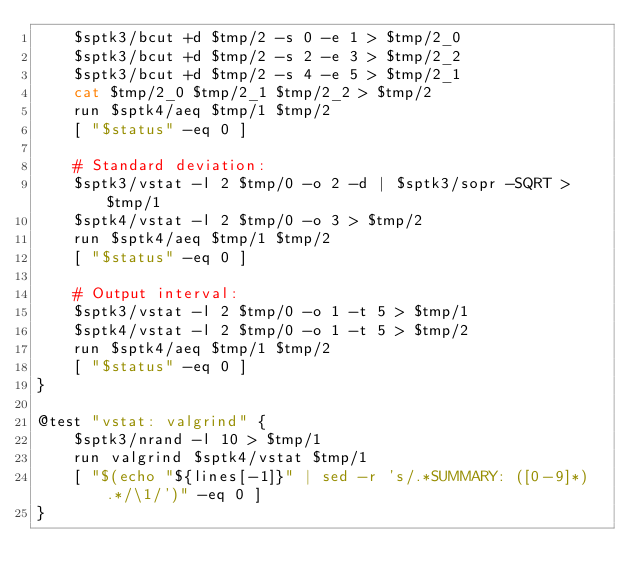<code> <loc_0><loc_0><loc_500><loc_500><_Bash_>    $sptk3/bcut +d $tmp/2 -s 0 -e 1 > $tmp/2_0
    $sptk3/bcut +d $tmp/2 -s 2 -e 3 > $tmp/2_2
    $sptk3/bcut +d $tmp/2 -s 4 -e 5 > $tmp/2_1
    cat $tmp/2_0 $tmp/2_1 $tmp/2_2 > $tmp/2
    run $sptk4/aeq $tmp/1 $tmp/2
    [ "$status" -eq 0 ]

    # Standard deviation:
    $sptk3/vstat -l 2 $tmp/0 -o 2 -d | $sptk3/sopr -SQRT > $tmp/1
    $sptk4/vstat -l 2 $tmp/0 -o 3 > $tmp/2
    run $sptk4/aeq $tmp/1 $tmp/2
    [ "$status" -eq 0 ]

    # Output interval:
    $sptk3/vstat -l 2 $tmp/0 -o 1 -t 5 > $tmp/1
    $sptk4/vstat -l 2 $tmp/0 -o 1 -t 5 > $tmp/2
    run $sptk4/aeq $tmp/1 $tmp/2
    [ "$status" -eq 0 ]
}

@test "vstat: valgrind" {
    $sptk3/nrand -l 10 > $tmp/1
    run valgrind $sptk4/vstat $tmp/1
    [ "$(echo "${lines[-1]}" | sed -r 's/.*SUMMARY: ([0-9]*) .*/\1/')" -eq 0 ]
}
</code> 